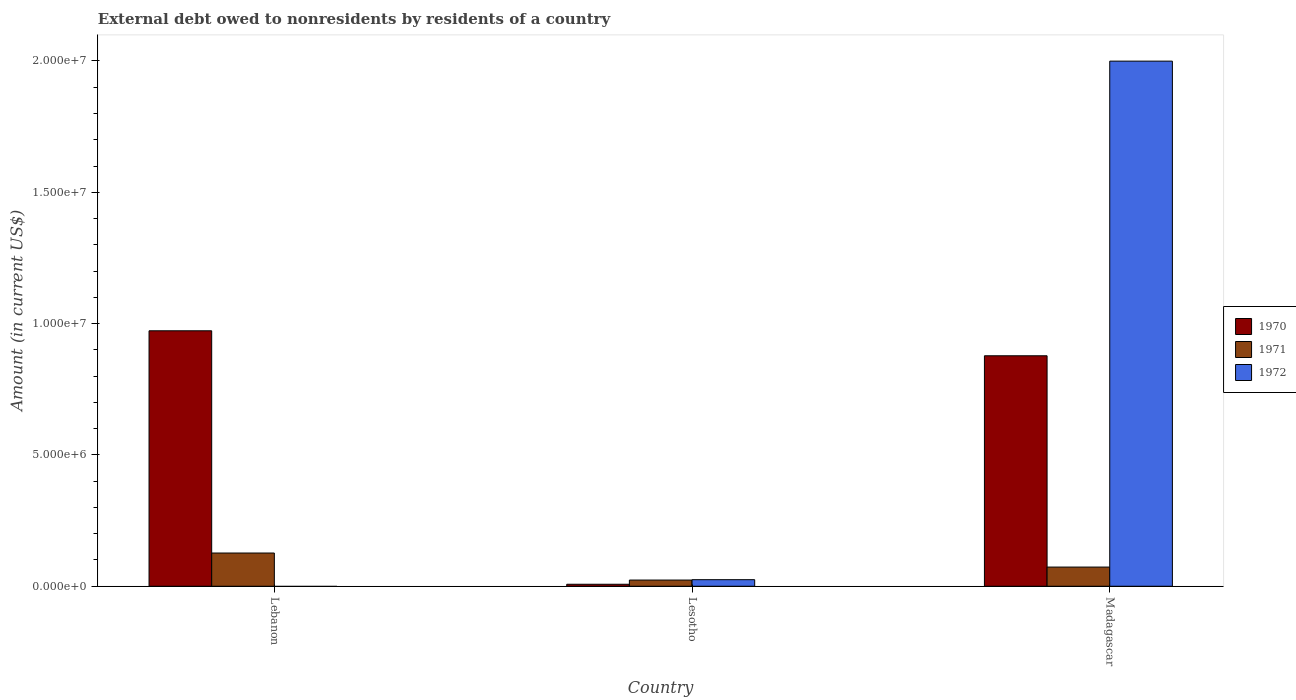How many different coloured bars are there?
Ensure brevity in your answer.  3. How many groups of bars are there?
Offer a very short reply. 3. Are the number of bars per tick equal to the number of legend labels?
Ensure brevity in your answer.  No. What is the label of the 2nd group of bars from the left?
Provide a succinct answer. Lesotho. In how many cases, is the number of bars for a given country not equal to the number of legend labels?
Offer a terse response. 1. What is the external debt owed by residents in 1972 in Lebanon?
Your answer should be very brief. 0. Across all countries, what is the maximum external debt owed by residents in 1970?
Your answer should be compact. 9.73e+06. Across all countries, what is the minimum external debt owed by residents in 1970?
Your answer should be compact. 7.60e+04. In which country was the external debt owed by residents in 1970 maximum?
Keep it short and to the point. Lebanon. What is the total external debt owed by residents in 1970 in the graph?
Your answer should be compact. 1.86e+07. What is the difference between the external debt owed by residents in 1971 in Lesotho and that in Madagascar?
Make the answer very short. -4.94e+05. What is the difference between the external debt owed by residents in 1972 in Lebanon and the external debt owed by residents in 1970 in Madagascar?
Provide a succinct answer. -8.78e+06. What is the average external debt owed by residents in 1970 per country?
Your answer should be compact. 6.19e+06. What is the difference between the external debt owed by residents of/in 1971 and external debt owed by residents of/in 1970 in Madagascar?
Make the answer very short. -8.04e+06. What is the ratio of the external debt owed by residents in 1970 in Lesotho to that in Madagascar?
Give a very brief answer. 0.01. Is the external debt owed by residents in 1971 in Lesotho less than that in Madagascar?
Your answer should be very brief. Yes. Is the difference between the external debt owed by residents in 1971 in Lesotho and Madagascar greater than the difference between the external debt owed by residents in 1970 in Lesotho and Madagascar?
Your response must be concise. Yes. What is the difference between the highest and the second highest external debt owed by residents in 1970?
Offer a very short reply. 9.65e+06. What is the difference between the highest and the lowest external debt owed by residents in 1971?
Your response must be concise. 1.03e+06. In how many countries, is the external debt owed by residents in 1972 greater than the average external debt owed by residents in 1972 taken over all countries?
Provide a short and direct response. 1. Is the sum of the external debt owed by residents in 1970 in Lesotho and Madagascar greater than the maximum external debt owed by residents in 1971 across all countries?
Ensure brevity in your answer.  Yes. How many bars are there?
Keep it short and to the point. 8. Does the graph contain grids?
Make the answer very short. No. What is the title of the graph?
Offer a very short reply. External debt owed to nonresidents by residents of a country. What is the label or title of the Y-axis?
Keep it short and to the point. Amount (in current US$). What is the Amount (in current US$) of 1970 in Lebanon?
Provide a short and direct response. 9.73e+06. What is the Amount (in current US$) of 1971 in Lebanon?
Your answer should be very brief. 1.26e+06. What is the Amount (in current US$) of 1972 in Lebanon?
Make the answer very short. 0. What is the Amount (in current US$) of 1970 in Lesotho?
Provide a short and direct response. 7.60e+04. What is the Amount (in current US$) in 1971 in Lesotho?
Give a very brief answer. 2.36e+05. What is the Amount (in current US$) in 1972 in Lesotho?
Offer a terse response. 2.50e+05. What is the Amount (in current US$) in 1970 in Madagascar?
Your response must be concise. 8.78e+06. What is the Amount (in current US$) of 1971 in Madagascar?
Keep it short and to the point. 7.30e+05. What is the Amount (in current US$) in 1972 in Madagascar?
Provide a short and direct response. 2.00e+07. Across all countries, what is the maximum Amount (in current US$) of 1970?
Your answer should be very brief. 9.73e+06. Across all countries, what is the maximum Amount (in current US$) of 1971?
Keep it short and to the point. 1.26e+06. Across all countries, what is the maximum Amount (in current US$) in 1972?
Give a very brief answer. 2.00e+07. Across all countries, what is the minimum Amount (in current US$) in 1970?
Give a very brief answer. 7.60e+04. Across all countries, what is the minimum Amount (in current US$) in 1971?
Provide a succinct answer. 2.36e+05. What is the total Amount (in current US$) in 1970 in the graph?
Your answer should be compact. 1.86e+07. What is the total Amount (in current US$) of 1971 in the graph?
Make the answer very short. 2.23e+06. What is the total Amount (in current US$) of 1972 in the graph?
Your response must be concise. 2.02e+07. What is the difference between the Amount (in current US$) in 1970 in Lebanon and that in Lesotho?
Give a very brief answer. 9.65e+06. What is the difference between the Amount (in current US$) of 1971 in Lebanon and that in Lesotho?
Provide a short and direct response. 1.03e+06. What is the difference between the Amount (in current US$) in 1970 in Lebanon and that in Madagascar?
Give a very brief answer. 9.51e+05. What is the difference between the Amount (in current US$) in 1971 in Lebanon and that in Madagascar?
Offer a terse response. 5.35e+05. What is the difference between the Amount (in current US$) of 1970 in Lesotho and that in Madagascar?
Give a very brief answer. -8.70e+06. What is the difference between the Amount (in current US$) of 1971 in Lesotho and that in Madagascar?
Offer a terse response. -4.94e+05. What is the difference between the Amount (in current US$) in 1972 in Lesotho and that in Madagascar?
Ensure brevity in your answer.  -1.97e+07. What is the difference between the Amount (in current US$) of 1970 in Lebanon and the Amount (in current US$) of 1971 in Lesotho?
Your response must be concise. 9.49e+06. What is the difference between the Amount (in current US$) of 1970 in Lebanon and the Amount (in current US$) of 1972 in Lesotho?
Keep it short and to the point. 9.48e+06. What is the difference between the Amount (in current US$) of 1971 in Lebanon and the Amount (in current US$) of 1972 in Lesotho?
Your response must be concise. 1.02e+06. What is the difference between the Amount (in current US$) of 1970 in Lebanon and the Amount (in current US$) of 1971 in Madagascar?
Provide a succinct answer. 9.00e+06. What is the difference between the Amount (in current US$) of 1970 in Lebanon and the Amount (in current US$) of 1972 in Madagascar?
Keep it short and to the point. -1.03e+07. What is the difference between the Amount (in current US$) in 1971 in Lebanon and the Amount (in current US$) in 1972 in Madagascar?
Offer a very short reply. -1.87e+07. What is the difference between the Amount (in current US$) in 1970 in Lesotho and the Amount (in current US$) in 1971 in Madagascar?
Give a very brief answer. -6.54e+05. What is the difference between the Amount (in current US$) in 1970 in Lesotho and the Amount (in current US$) in 1972 in Madagascar?
Provide a short and direct response. -1.99e+07. What is the difference between the Amount (in current US$) of 1971 in Lesotho and the Amount (in current US$) of 1972 in Madagascar?
Make the answer very short. -1.98e+07. What is the average Amount (in current US$) in 1970 per country?
Give a very brief answer. 6.19e+06. What is the average Amount (in current US$) in 1971 per country?
Give a very brief answer. 7.44e+05. What is the average Amount (in current US$) of 1972 per country?
Provide a succinct answer. 6.75e+06. What is the difference between the Amount (in current US$) in 1970 and Amount (in current US$) in 1971 in Lebanon?
Offer a terse response. 8.46e+06. What is the difference between the Amount (in current US$) of 1970 and Amount (in current US$) of 1972 in Lesotho?
Your response must be concise. -1.74e+05. What is the difference between the Amount (in current US$) of 1971 and Amount (in current US$) of 1972 in Lesotho?
Your answer should be very brief. -1.40e+04. What is the difference between the Amount (in current US$) of 1970 and Amount (in current US$) of 1971 in Madagascar?
Your answer should be very brief. 8.04e+06. What is the difference between the Amount (in current US$) of 1970 and Amount (in current US$) of 1972 in Madagascar?
Provide a succinct answer. -1.12e+07. What is the difference between the Amount (in current US$) in 1971 and Amount (in current US$) in 1972 in Madagascar?
Offer a very short reply. -1.93e+07. What is the ratio of the Amount (in current US$) in 1970 in Lebanon to that in Lesotho?
Provide a short and direct response. 127.97. What is the ratio of the Amount (in current US$) of 1971 in Lebanon to that in Lesotho?
Offer a very short reply. 5.36. What is the ratio of the Amount (in current US$) of 1970 in Lebanon to that in Madagascar?
Give a very brief answer. 1.11. What is the ratio of the Amount (in current US$) of 1971 in Lebanon to that in Madagascar?
Offer a terse response. 1.73. What is the ratio of the Amount (in current US$) in 1970 in Lesotho to that in Madagascar?
Your response must be concise. 0.01. What is the ratio of the Amount (in current US$) of 1971 in Lesotho to that in Madagascar?
Provide a short and direct response. 0.32. What is the ratio of the Amount (in current US$) in 1972 in Lesotho to that in Madagascar?
Ensure brevity in your answer.  0.01. What is the difference between the highest and the second highest Amount (in current US$) in 1970?
Make the answer very short. 9.51e+05. What is the difference between the highest and the second highest Amount (in current US$) in 1971?
Offer a terse response. 5.35e+05. What is the difference between the highest and the lowest Amount (in current US$) of 1970?
Offer a very short reply. 9.65e+06. What is the difference between the highest and the lowest Amount (in current US$) of 1971?
Make the answer very short. 1.03e+06. What is the difference between the highest and the lowest Amount (in current US$) of 1972?
Your response must be concise. 2.00e+07. 